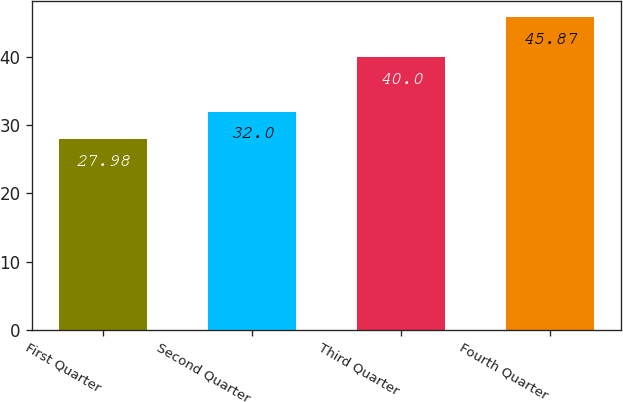Convert chart. <chart><loc_0><loc_0><loc_500><loc_500><bar_chart><fcel>First Quarter<fcel>Second Quarter<fcel>Third Quarter<fcel>Fourth Quarter<nl><fcel>27.98<fcel>32<fcel>40<fcel>45.87<nl></chart> 